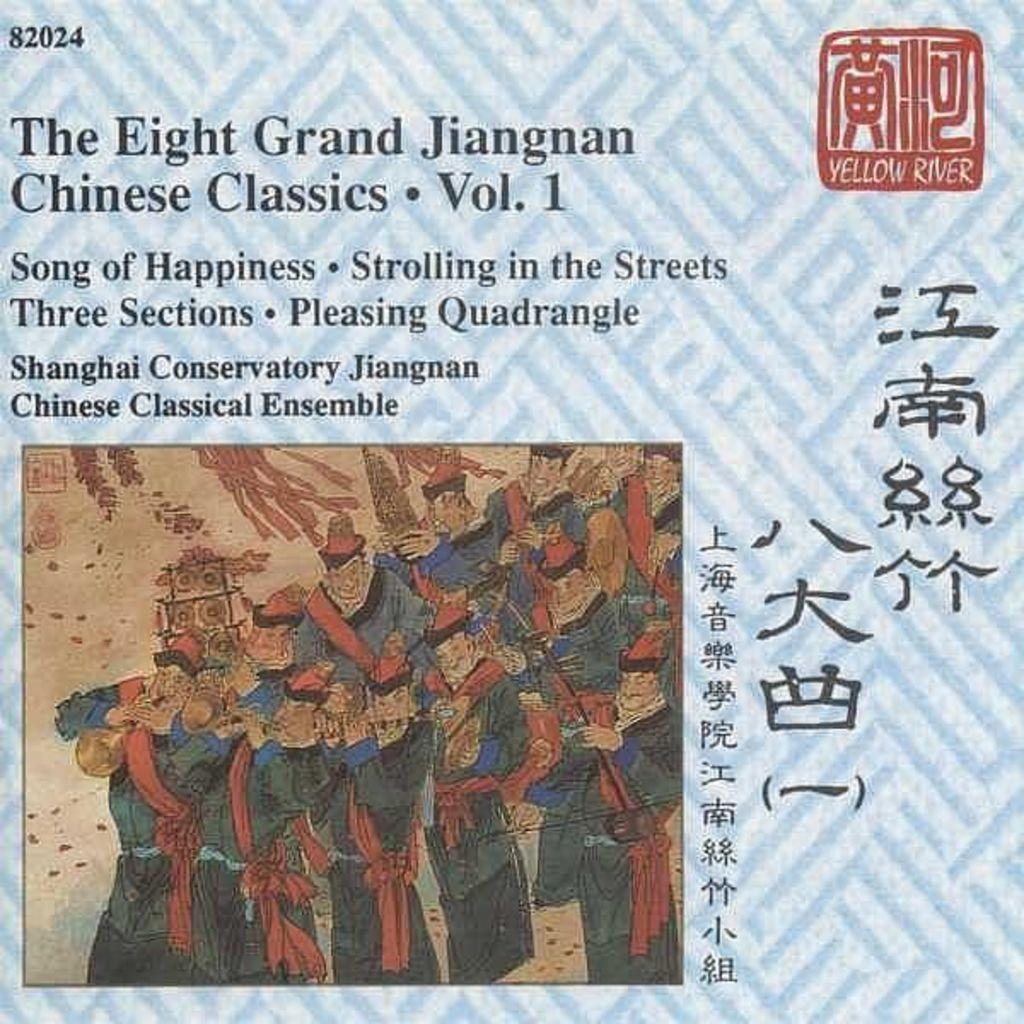Please provide a concise description of this image. In this image we can see a poster with text and and an image. 